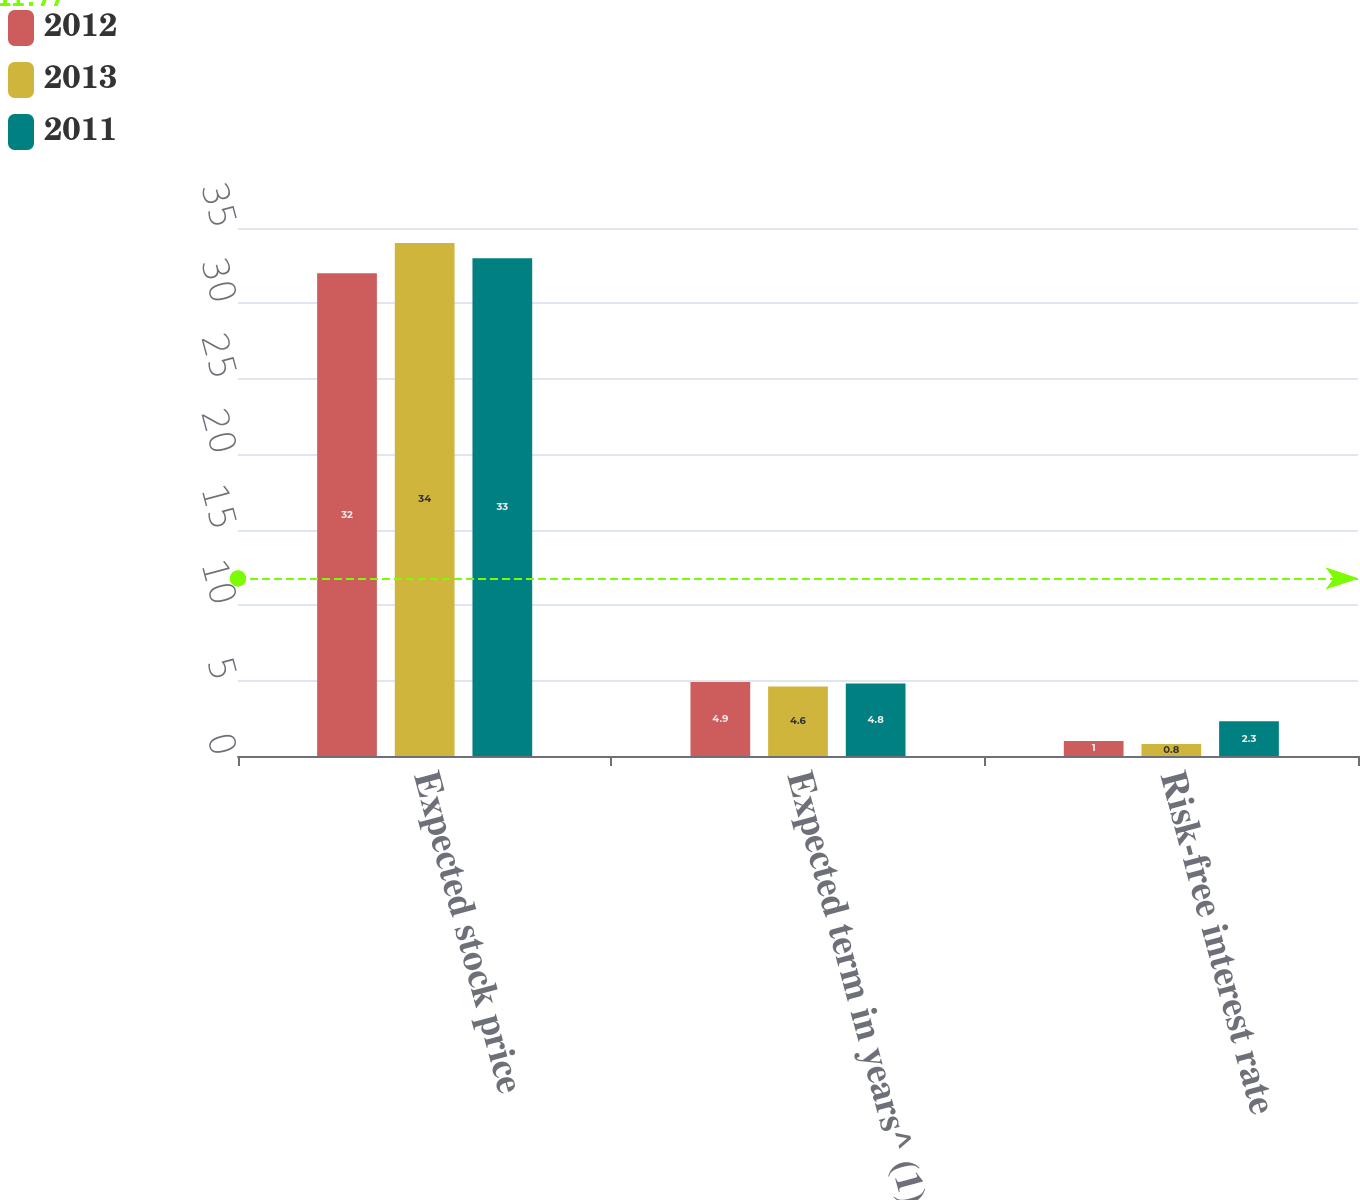Convert chart to OTSL. <chart><loc_0><loc_0><loc_500><loc_500><stacked_bar_chart><ecel><fcel>Expected stock price<fcel>Expected term in years^ (1)<fcel>Risk-free interest rate<nl><fcel>2012<fcel>32<fcel>4.9<fcel>1<nl><fcel>2013<fcel>34<fcel>4.6<fcel>0.8<nl><fcel>2011<fcel>33<fcel>4.8<fcel>2.3<nl></chart> 